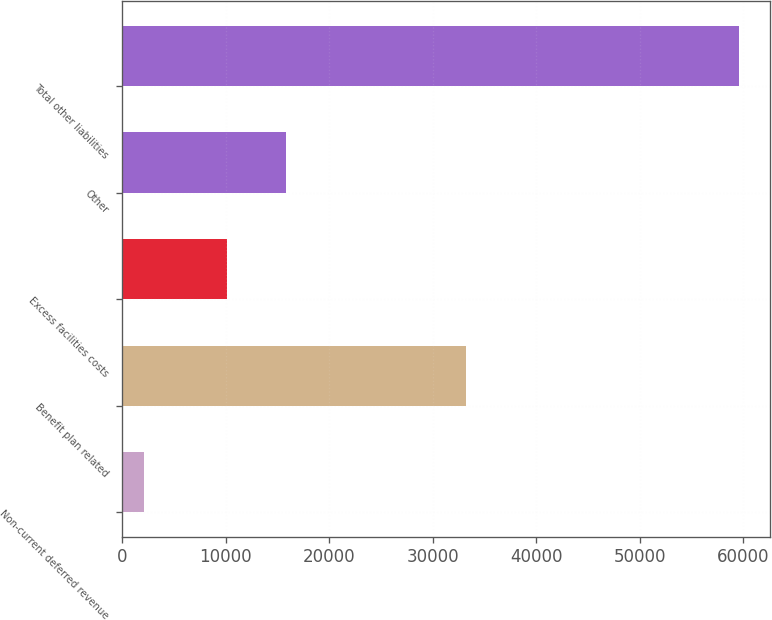<chart> <loc_0><loc_0><loc_500><loc_500><bar_chart><fcel>Non-current deferred revenue<fcel>Benefit plan related<fcel>Excess facilities costs<fcel>Other<fcel>Total other liabilities<nl><fcel>2148<fcel>33254<fcel>10134<fcel>15878.4<fcel>59592<nl></chart> 